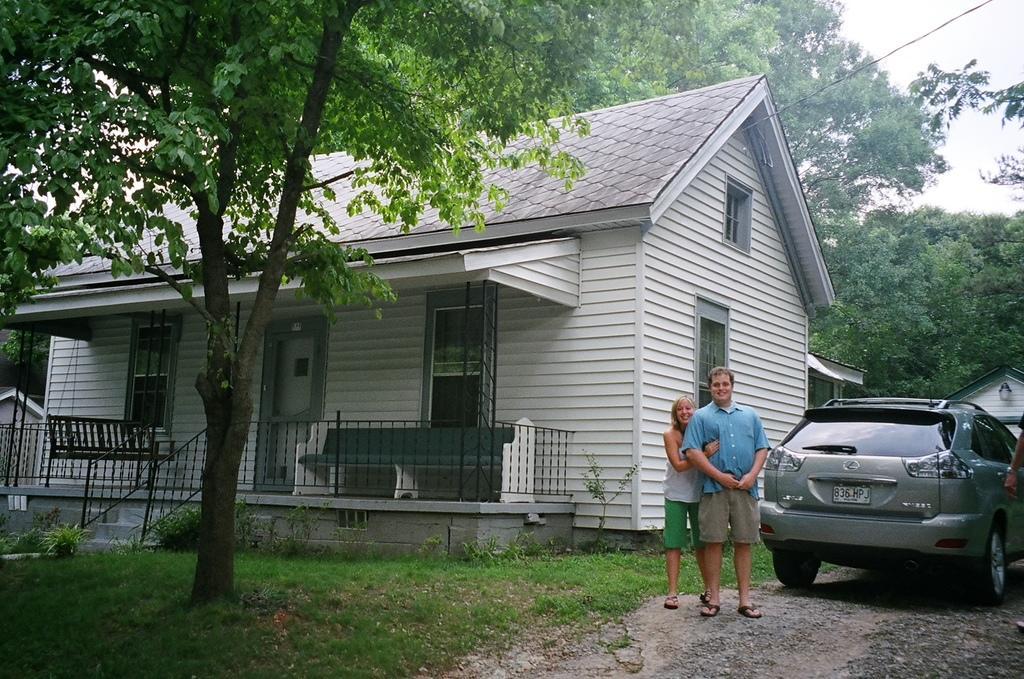Please provide a concise description of this image. In this image there is a couple standing on a road, behind them there is a house, car, behind the house there are trees, on the bottom left there is grassland and a tree. 